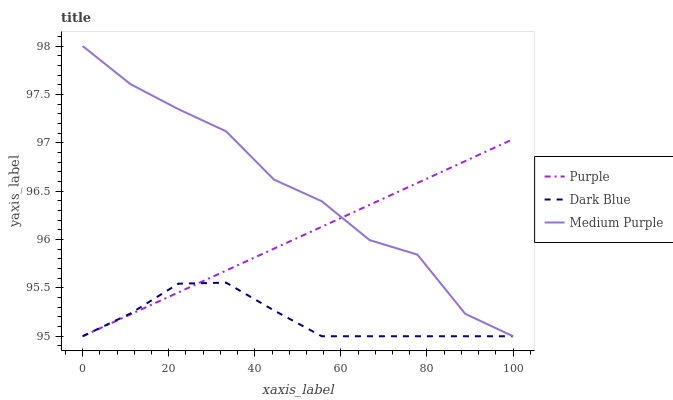Does Dark Blue have the minimum area under the curve?
Answer yes or no. Yes. Does Medium Purple have the maximum area under the curve?
Answer yes or no. Yes. Does Medium Purple have the minimum area under the curve?
Answer yes or no. No. Does Dark Blue have the maximum area under the curve?
Answer yes or no. No. Is Purple the smoothest?
Answer yes or no. Yes. Is Medium Purple the roughest?
Answer yes or no. Yes. Is Dark Blue the smoothest?
Answer yes or no. No. Is Dark Blue the roughest?
Answer yes or no. No. Does Purple have the lowest value?
Answer yes or no. Yes. Does Medium Purple have the highest value?
Answer yes or no. Yes. Does Dark Blue have the highest value?
Answer yes or no. No. Does Medium Purple intersect Dark Blue?
Answer yes or no. Yes. Is Medium Purple less than Dark Blue?
Answer yes or no. No. Is Medium Purple greater than Dark Blue?
Answer yes or no. No. 